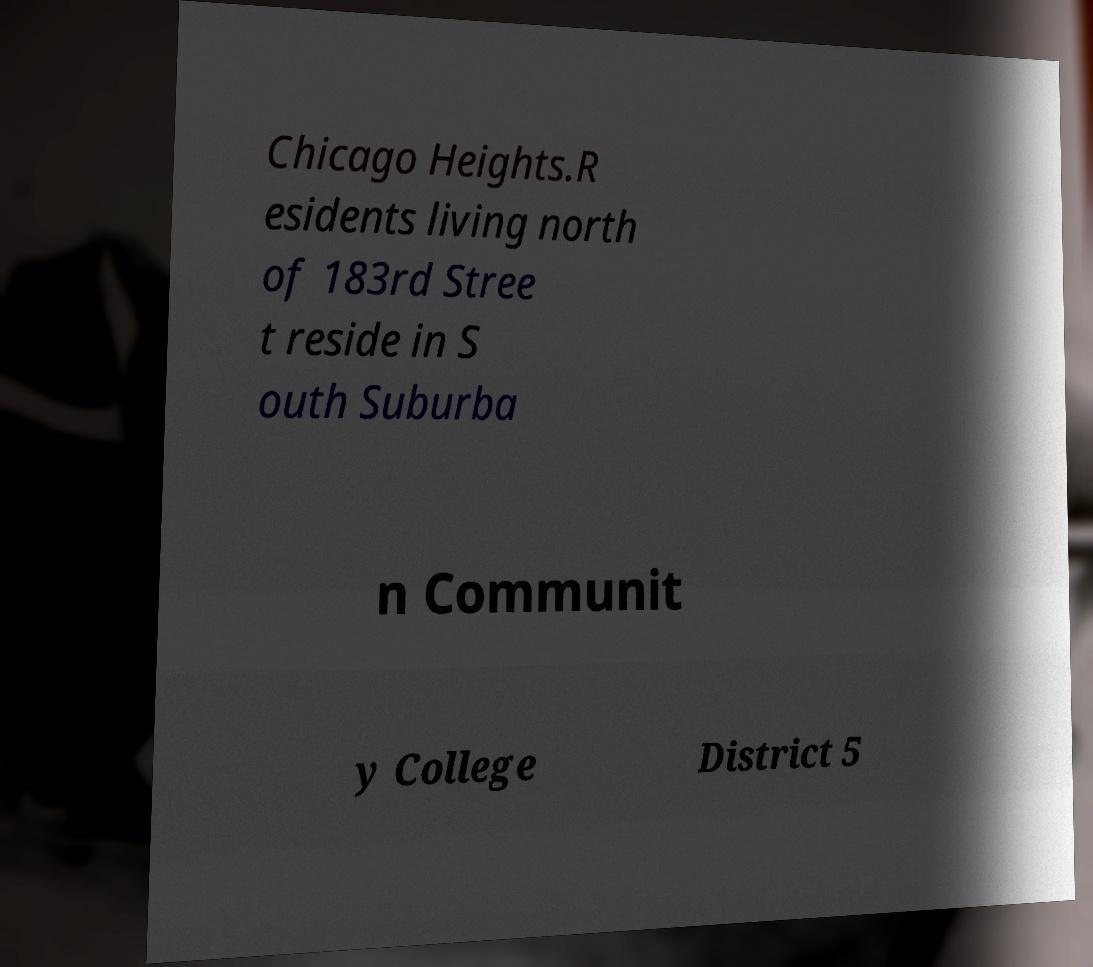Could you extract and type out the text from this image? Chicago Heights.R esidents living north of 183rd Stree t reside in S outh Suburba n Communit y College District 5 